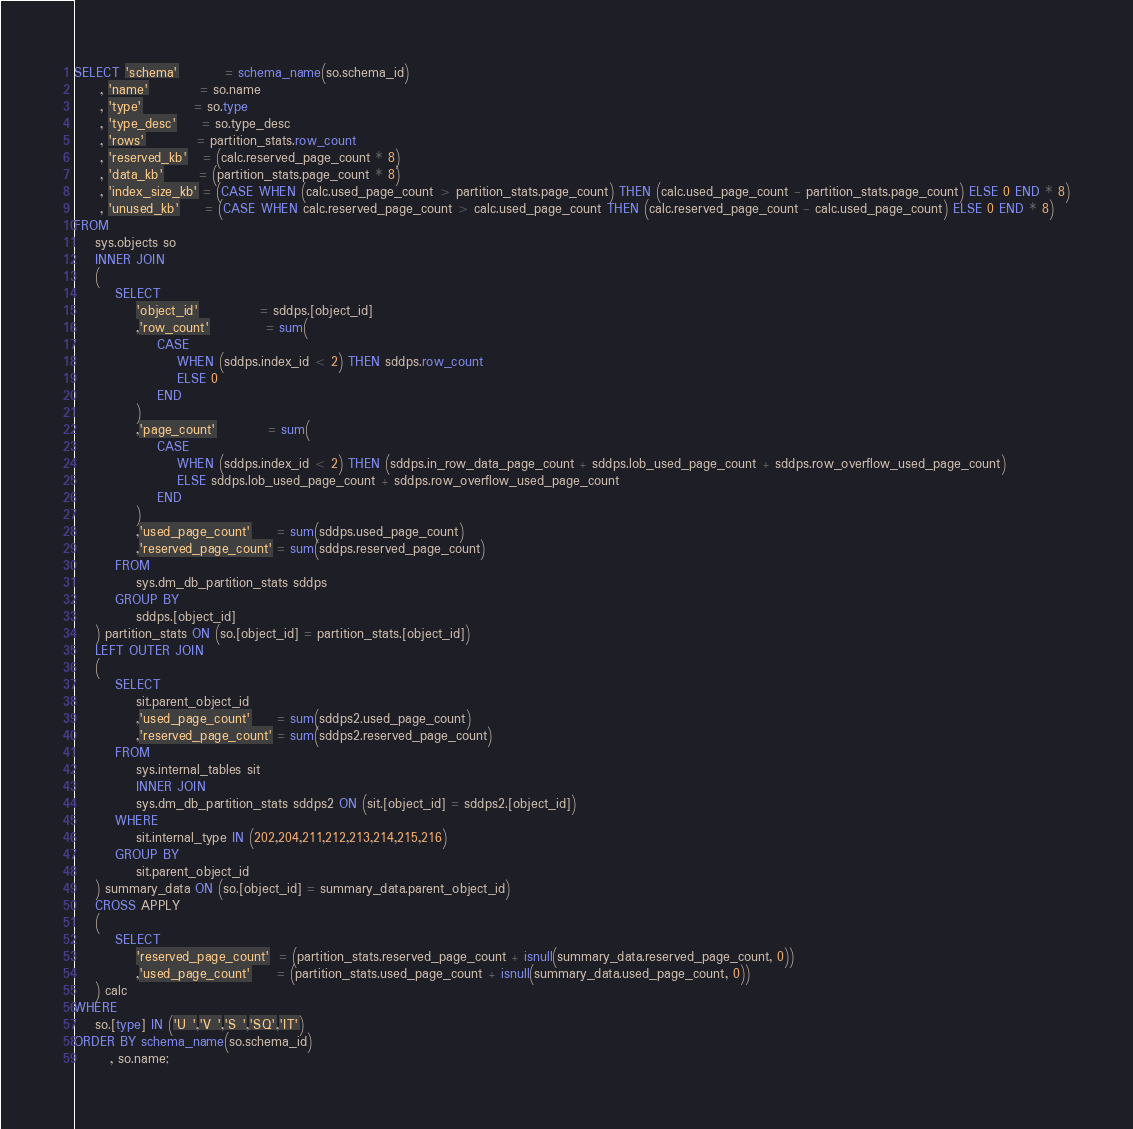<code> <loc_0><loc_0><loc_500><loc_500><_SQL_>SELECT 'schema'         = schema_name(so.schema_id)
     , 'name'          = so.name
     , 'type'          = so.type
     , 'type_desc'     = so.type_desc
     , 'rows'          = partition_stats.row_count
     , 'reserved_kb'   = (calc.reserved_page_count * 8)
     , 'data_kb'       = (partition_stats.page_count * 8)
     , 'index_size_kb' = (CASE WHEN (calc.used_page_count > partition_stats.page_count) THEN (calc.used_page_count - partition_stats.page_count) ELSE 0 END * 8)
     , 'unused_kb'     = (CASE WHEN calc.reserved_page_count > calc.used_page_count THEN (calc.reserved_page_count - calc.used_page_count) ELSE 0 END * 8)
FROM
    sys.objects so
    INNER JOIN
    (
        SELECT
            'object_id'            = sddps.[object_id]
            ,'row_count'           = sum(
                CASE
                    WHEN (sddps.index_id < 2) THEN sddps.row_count
                    ELSE 0
                END
            )
            ,'page_count'          = sum(
                CASE
                    WHEN (sddps.index_id < 2) THEN (sddps.in_row_data_page_count + sddps.lob_used_page_count + sddps.row_overflow_used_page_count)
                    ELSE sddps.lob_used_page_count + sddps.row_overflow_used_page_count
                END
            )
            ,'used_page_count'     = sum(sddps.used_page_count)
            ,'reserved_page_count' = sum(sddps.reserved_page_count)
        FROM
            sys.dm_db_partition_stats sddps
        GROUP BY
            sddps.[object_id]
    ) partition_stats ON (so.[object_id] = partition_stats.[object_id])
    LEFT OUTER JOIN
    (
        SELECT
            sit.parent_object_id
            ,'used_page_count'     = sum(sddps2.used_page_count)
            ,'reserved_page_count' = sum(sddps2.reserved_page_count)
        FROM
            sys.internal_tables sit
            INNER JOIN
            sys.dm_db_partition_stats sddps2 ON (sit.[object_id] = sddps2.[object_id])
        WHERE
            sit.internal_type IN (202,204,211,212,213,214,215,216)
        GROUP BY
            sit.parent_object_id
    ) summary_data ON (so.[object_id] = summary_data.parent_object_id)
    CROSS APPLY
    (
        SELECT
            'reserved_page_count'  = (partition_stats.reserved_page_count + isnull(summary_data.reserved_page_count, 0))
            ,'used_page_count'     = (partition_stats.used_page_count + isnull(summary_data.used_page_count, 0))
    ) calc
WHERE
    so.[type] IN ('U ','V ','S ','SQ','IT')
ORDER BY schema_name(so.schema_id)
       , so.name;
</code> 